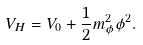<formula> <loc_0><loc_0><loc_500><loc_500>V _ { H } = V _ { 0 } + \frac { 1 } { 2 } m _ { \phi } ^ { 2 } \phi ^ { 2 } .</formula> 